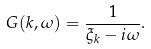Convert formula to latex. <formula><loc_0><loc_0><loc_500><loc_500>G ( { k } , \omega ) = \frac { 1 } { \xi _ { k } - i \omega } .</formula> 